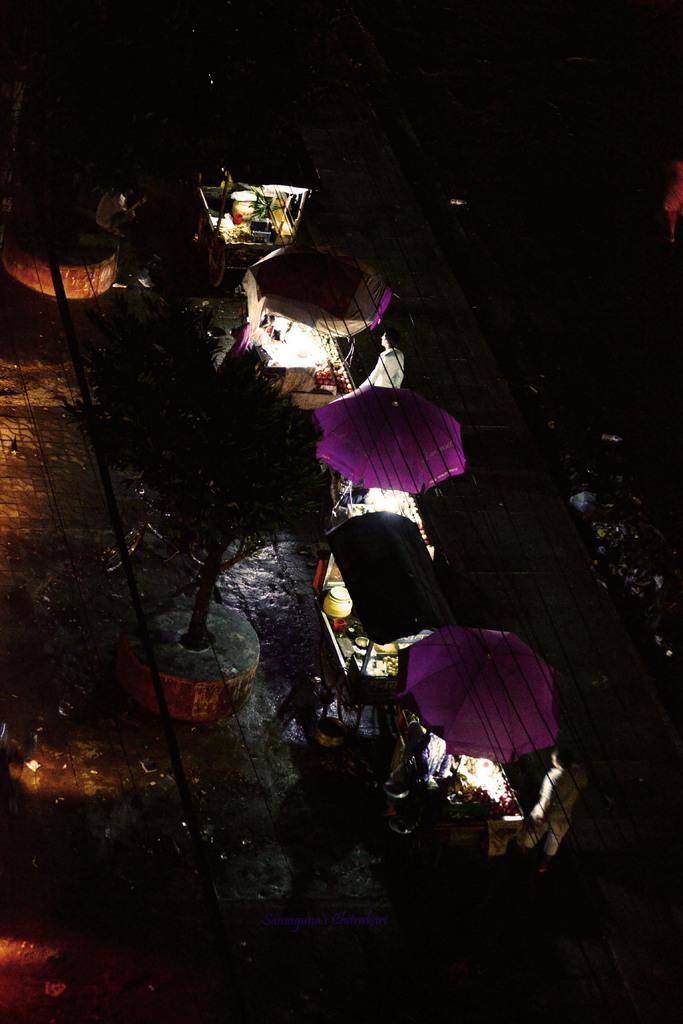What type of structures are present in the image? There are stalls in the image. What can be seen illuminating the area in the image? There are lights in the image. What type of natural element is present in the image? There is a tree in the image. What is visible on the ground in the image? There are objects on the ground in the image. How would you describe the lighting conditions in the image? The image is a little bit dark. What type of pot is being used by the spy in the image? There is no spy or pot present in the image. Where is the sofa located in the image? There is no sofa present in the image. 